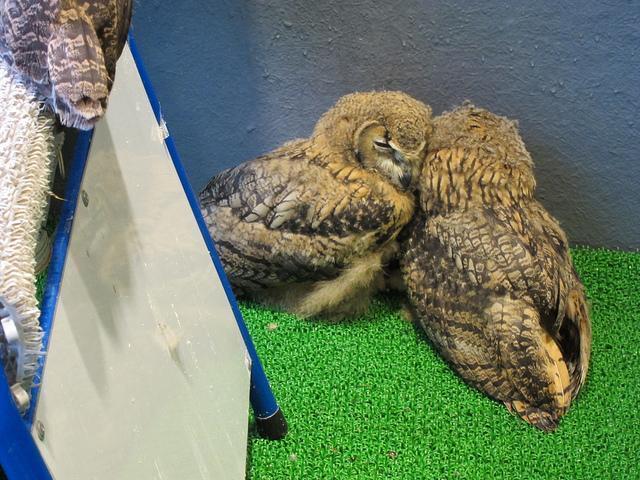How many birds can be seen?
Give a very brief answer. 3. How many levels does the bus featured in the picture have?
Give a very brief answer. 0. 